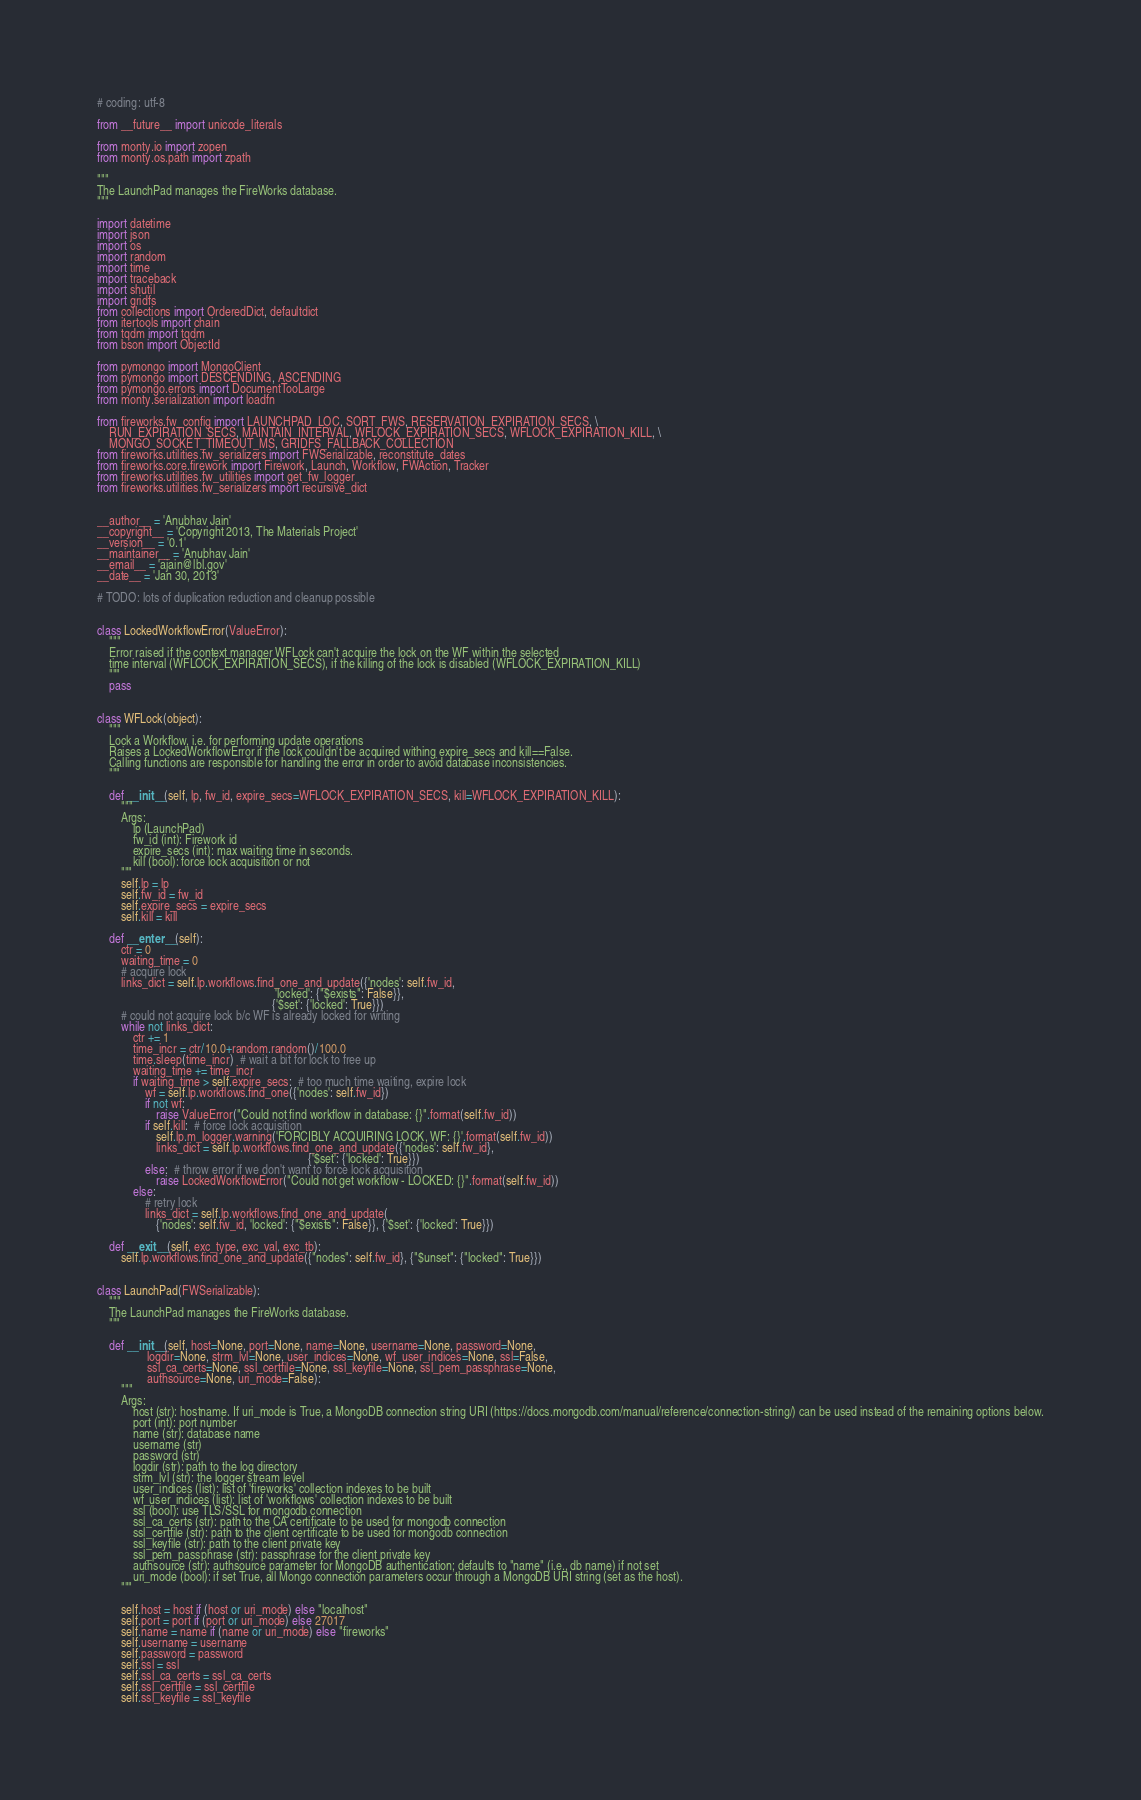<code> <loc_0><loc_0><loc_500><loc_500><_Python_># coding: utf-8

from __future__ import unicode_literals

from monty.io import zopen
from monty.os.path import zpath

"""
The LaunchPad manages the FireWorks database.
"""

import datetime
import json
import os
import random
import time
import traceback
import shutil
import gridfs
from collections import OrderedDict, defaultdict
from itertools import chain
from tqdm import tqdm
from bson import ObjectId

from pymongo import MongoClient
from pymongo import DESCENDING, ASCENDING
from pymongo.errors import DocumentTooLarge
from monty.serialization import loadfn

from fireworks.fw_config import LAUNCHPAD_LOC, SORT_FWS, RESERVATION_EXPIRATION_SECS, \
    RUN_EXPIRATION_SECS, MAINTAIN_INTERVAL, WFLOCK_EXPIRATION_SECS, WFLOCK_EXPIRATION_KILL, \
    MONGO_SOCKET_TIMEOUT_MS, GRIDFS_FALLBACK_COLLECTION
from fireworks.utilities.fw_serializers import FWSerializable, reconstitute_dates
from fireworks.core.firework import Firework, Launch, Workflow, FWAction, Tracker
from fireworks.utilities.fw_utilities import get_fw_logger
from fireworks.utilities.fw_serializers import recursive_dict


__author__ = 'Anubhav Jain'
__copyright__ = 'Copyright 2013, The Materials Project'
__version__ = '0.1'
__maintainer__ = 'Anubhav Jain'
__email__ = 'ajain@lbl.gov'
__date__ = 'Jan 30, 2013'

# TODO: lots of duplication reduction and cleanup possible


class LockedWorkflowError(ValueError):
    """
    Error raised if the context manager WFLock can't acquire the lock on the WF within the selected
    time interval (WFLOCK_EXPIRATION_SECS), if the killing of the lock is disabled (WFLOCK_EXPIRATION_KILL)
    """
    pass


class WFLock(object):
    """
    Lock a Workflow, i.e. for performing update operations
    Raises a LockedWorkflowError if the lock couldn't be acquired withing expire_secs and kill==False.
    Calling functions are responsible for handling the error in order to avoid database inconsistencies.
    """

    def __init__(self, lp, fw_id, expire_secs=WFLOCK_EXPIRATION_SECS, kill=WFLOCK_EXPIRATION_KILL):
        """
        Args:
            lp (LaunchPad)
            fw_id (int): Firework id
            expire_secs (int): max waiting time in seconds.
            kill (bool): force lock acquisition or not
        """
        self.lp = lp
        self.fw_id = fw_id
        self.expire_secs = expire_secs
        self.kill = kill

    def __enter__(self):
        ctr = 0
        waiting_time = 0
        # acquire lock
        links_dict = self.lp.workflows.find_one_and_update({'nodes': self.fw_id,
                                                            'locked': {"$exists": False}},
                                                           {'$set': {'locked': True}})
        # could not acquire lock b/c WF is already locked for writing
        while not links_dict:
            ctr += 1
            time_incr = ctr/10.0+random.random()/100.0
            time.sleep(time_incr)  # wait a bit for lock to free up
            waiting_time += time_incr
            if waiting_time > self.expire_secs:  # too much time waiting, expire lock
                wf = self.lp.workflows.find_one({'nodes': self.fw_id})
                if not wf:
                    raise ValueError("Could not find workflow in database: {}".format(self.fw_id))
                if self.kill:  # force lock acquisition
                    self.lp.m_logger.warning('FORCIBLY ACQUIRING LOCK, WF: {}'.format(self.fw_id))
                    links_dict = self.lp.workflows.find_one_and_update({'nodes': self.fw_id},
                                                                       {'$set': {'locked': True}})
                else:  # throw error if we don't want to force lock acquisition
                    raise LockedWorkflowError("Could not get workflow - LOCKED: {}".format(self.fw_id))
            else:
                # retry lock
                links_dict = self.lp.workflows.find_one_and_update(
                    {'nodes': self.fw_id, 'locked': {"$exists": False}}, {'$set': {'locked': True}})

    def __exit__(self, exc_type, exc_val, exc_tb):
        self.lp.workflows.find_one_and_update({"nodes": self.fw_id}, {"$unset": {"locked": True}})


class LaunchPad(FWSerializable):
    """
    The LaunchPad manages the FireWorks database.
    """

    def __init__(self, host=None, port=None, name=None, username=None, password=None,
                 logdir=None, strm_lvl=None, user_indices=None, wf_user_indices=None, ssl=False,
                 ssl_ca_certs=None, ssl_certfile=None, ssl_keyfile=None, ssl_pem_passphrase=None,
                 authsource=None, uri_mode=False):
        """
        Args:
            host (str): hostname. If uri_mode is True, a MongoDB connection string URI (https://docs.mongodb.com/manual/reference/connection-string/) can be used instead of the remaining options below.
            port (int): port number
            name (str): database name
            username (str)
            password (str)
            logdir (str): path to the log directory
            strm_lvl (str): the logger stream level
            user_indices (list): list of 'fireworks' collection indexes to be built
            wf_user_indices (list): list of 'workflows' collection indexes to be built
            ssl (bool): use TLS/SSL for mongodb connection
            ssl_ca_certs (str): path to the CA certificate to be used for mongodb connection
            ssl_certfile (str): path to the client certificate to be used for mongodb connection
            ssl_keyfile (str): path to the client private key
            ssl_pem_passphrase (str): passphrase for the client private key
            authsource (str): authsource parameter for MongoDB authentication; defaults to "name" (i.e., db name) if not set
            uri_mode (bool): if set True, all Mongo connection parameters occur through a MongoDB URI string (set as the host).
        """

        self.host = host if (host or uri_mode) else "localhost"
        self.port = port if (port or uri_mode) else 27017
        self.name = name if (name or uri_mode) else "fireworks"
        self.username = username
        self.password = password
        self.ssl = ssl
        self.ssl_ca_certs = ssl_ca_certs
        self.ssl_certfile = ssl_certfile
        self.ssl_keyfile = ssl_keyfile</code> 